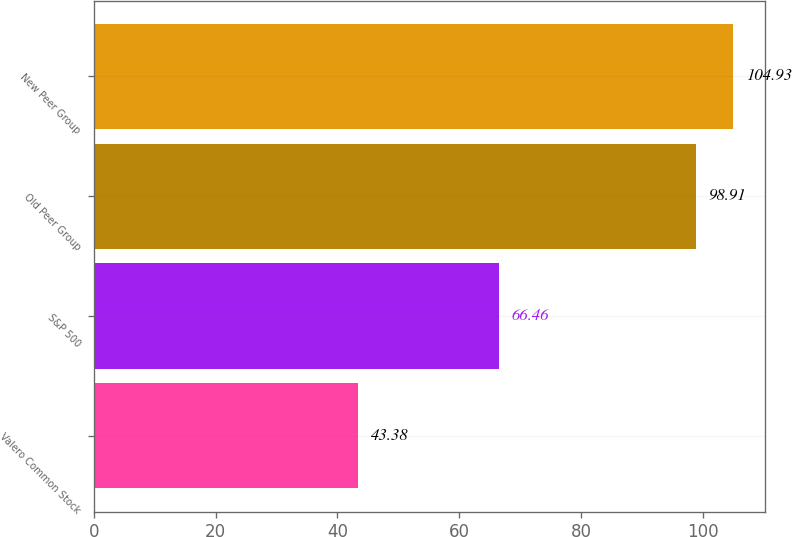<chart> <loc_0><loc_0><loc_500><loc_500><bar_chart><fcel>Valero Common Stock<fcel>S&P 500<fcel>Old Peer Group<fcel>New Peer Group<nl><fcel>43.38<fcel>66.46<fcel>98.91<fcel>104.93<nl></chart> 